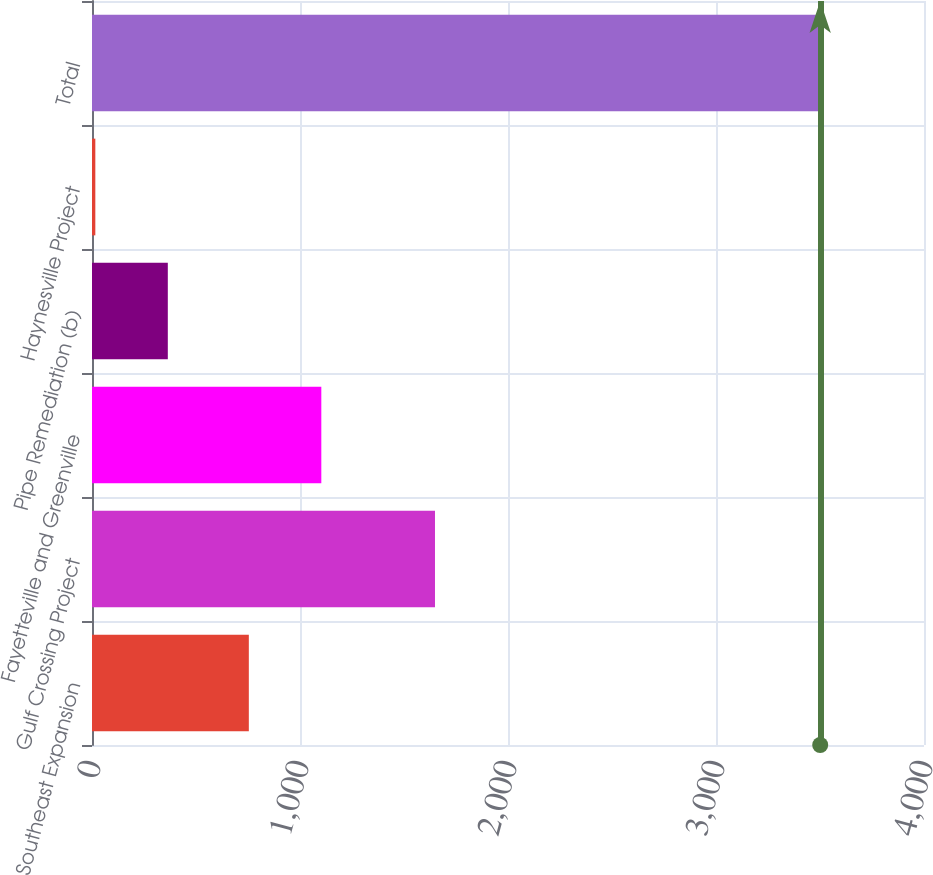<chart> <loc_0><loc_0><loc_500><loc_500><bar_chart><fcel>Southeast Expansion<fcel>Gulf Crossing Project<fcel>Fayetteville and Greenville<fcel>Pipe Remediation (b)<fcel>Haynesville Project<fcel>Total<nl><fcel>754<fcel>1649<fcel>1102.5<fcel>364.5<fcel>16<fcel>3501<nl></chart> 